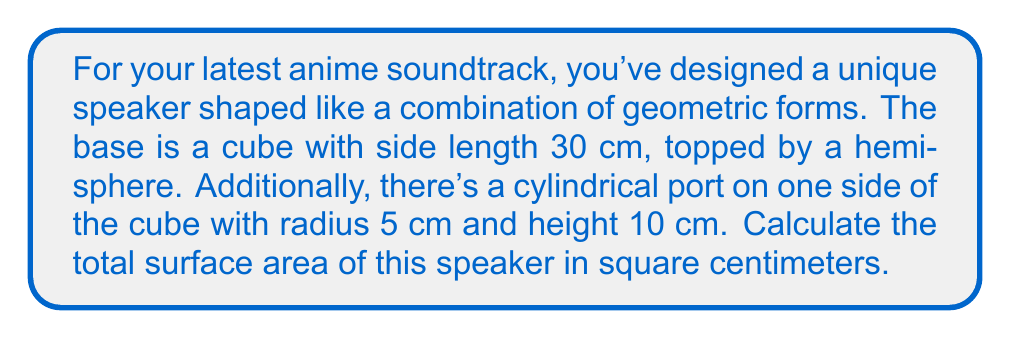Could you help me with this problem? Let's break this down step-by-step:

1) Surface area of the cube (excluding the top face and the circular area where the cylinder is attached):
   $$SA_{cube} = 5 \cdot 30^2 = 4500 \text{ cm}^2$$

2) Surface area of the hemisphere:
   $$SA_{hemisphere} = 2\pi r^2 = 2\pi \cdot 15^2 = 1413.72 \text{ cm}^2$$

3) Surface area of the cylinder (excluding the circular face attached to the cube):
   $$SA_{cylinder} = 2\pi rh + \pi r^2 = 2\pi \cdot 5 \cdot 10 + \pi \cdot 5^2 = 392.70 \text{ cm}^2$$

4) Area of the circular face on the cube that's replaced by the cylinder:
   $$A_{circle} = \pi r^2 = \pi \cdot 5^2 = 78.54 \text{ cm}^2$$

5) Total surface area:
   $$SA_{total} = SA_{cube} + SA_{hemisphere} + SA_{cylinder} - A_{circle}$$
   $$SA_{total} = 4500 + 1413.72 + 392.70 - 78.54 = 6227.88 \text{ cm}^2$$

[asy]
import three;

size(200);

// Define the cube
draw((0,0,0)--(30,0,0)--(30,30,0)--(0,30,0)--cycle);
draw((0,0,0)--(0,0,30)--(30,0,30)--(30,0,0));
draw((0,30,0)--(0,30,30)--(30,30,30)--(30,30,0));
draw((0,0,30)--(0,30,30));
draw((30,0,30)--(30,30,30));

// Draw the hemisphere
draw(arc((15,15,30),(30,15,30),(15,30,30)));
draw(arc((15,15,30),(15,0,30),(30,15,30)),dashed);
draw(arc((15,15,30),(0,15,30),(15,30,30)),dashed);

// Draw the cylinder
draw(circle((0,15,15),5));
draw((0,10,15)--(10,10,15));
draw((0,20,15)--(10,20,15));

label("30 cm", (15,-5,0));
label("r=15 cm", (25,15,35));
label("r=5 cm", (-8,15,15));
label("h=10 cm", (5,25,15));
[/asy]
Answer: 6227.88 cm² 